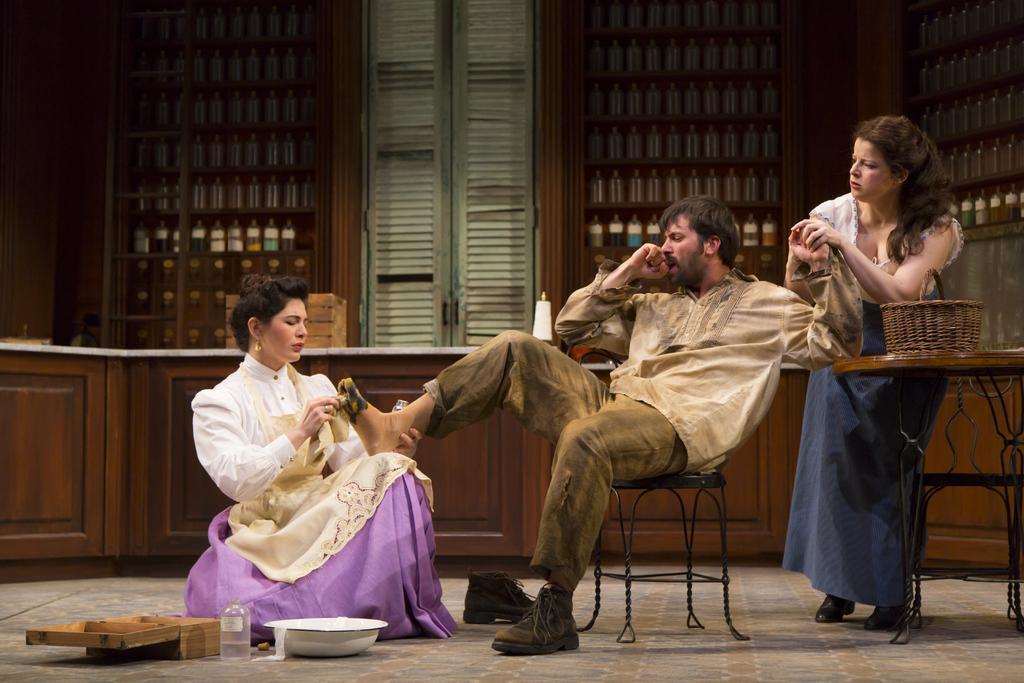How would you summarize this image in a sentence or two? This picture is taken inside a room. In this image, on the right side, we can see a woman standing in front of the table, on that table, we can see a basket. In the background of the image, we can see a man sitting on the chair. On the left side, we can see a woman is in squat position and holding the leg of a person in her hand. In the background, we can see some bottles on the shelf, door and a table. At the bottom, we can see a bowl, bottle and a wood box. 